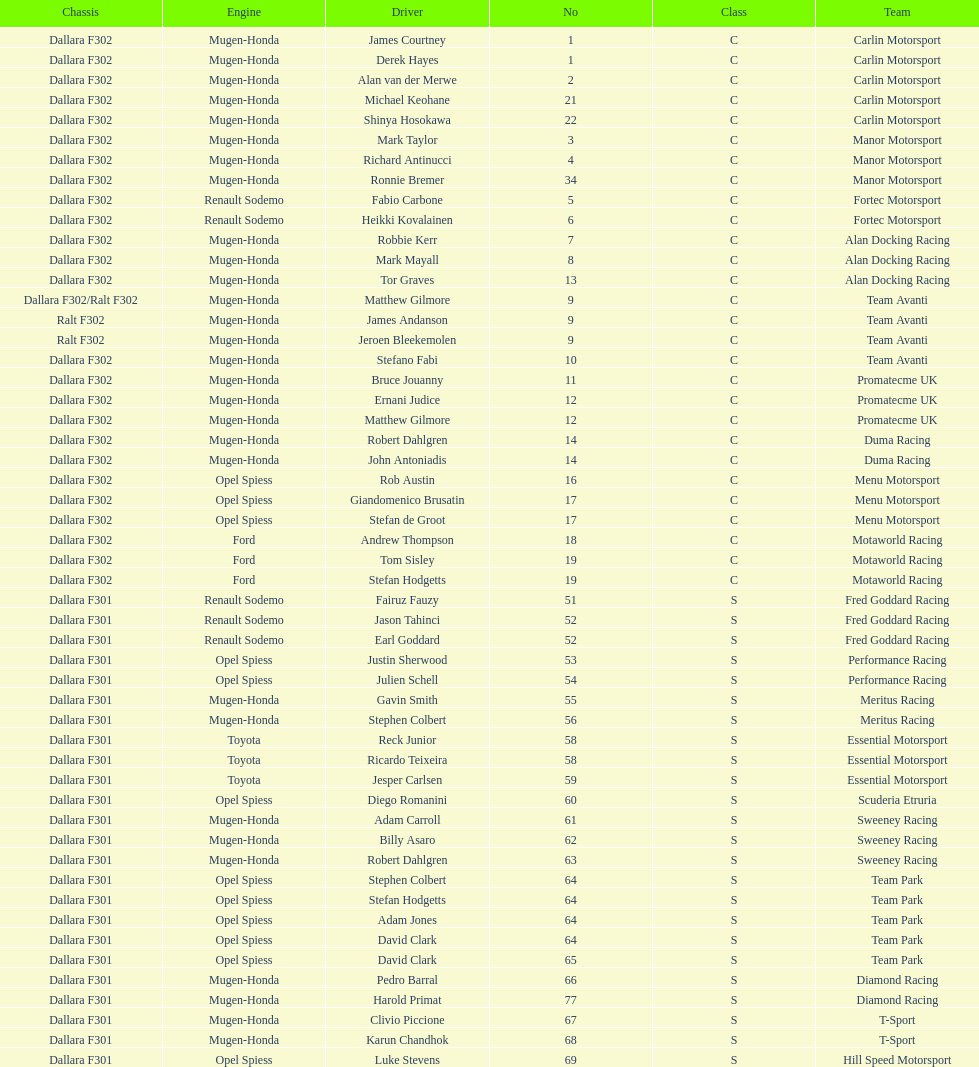What is the total number of class c (championship) teams? 21. 